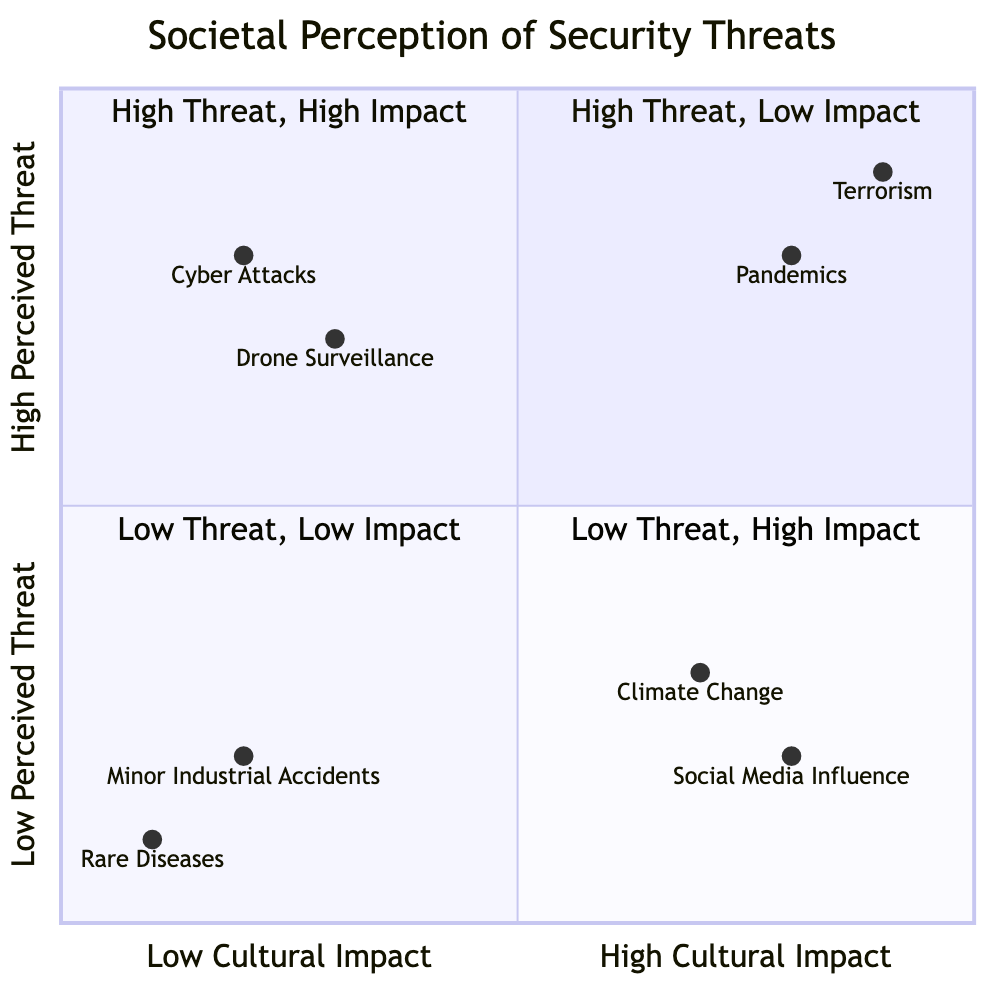What is the example for "Terrorism"? The diagram indicates that the example for "Terrorism" is "9/11 Attacks".
Answer: 9/11 Attacks How many nodes are in the "High Perceived Threat, High Cultural Impact" quadrant? The quadrant contains two nodes: "Terrorism" and "Pandemics". Thus the total count is 2.
Answer: 2 What is the perceived threat level of "Climate Change"? According to the diagram, "Climate Change" is located in the "Low Perceived Threat" category.
Answer: Low Which security threat is associated with the highest cultural impact? The diagram shows that "Terrorism" is positioned at the highest end of the cultural impact axis, indicating it has the highest cultural impact.
Answer: Terrorism Which two threats have a high perceived threat but low cultural impact? The threats "Cyber Attacks on Financial Institutions" and "Drone Surveillance" are represented in the "High Perceived Threat, Low Cultural Impact" quadrant.
Answer: Cyber Attacks on Financial Institutions and Drone Surveillance What is the cultural impact level for "Social Media Influence"? The diagram places "Social Media Influence" in the "High Cultural Impact" section, indicating its cultural impact is high.
Answer: High What threat has the least perceived threat and cultural impact? The diagram identifies "Rare Diseases" in the "Low Perceived Threat, Low Cultural Impact" quadrant, indicating it has both minimal threat levels.
Answer: Rare Diseases In which quadrant is "COVID-19 Pandemic" found? "COVID-19 Pandemic" is located in the "High Perceived Threat, High Cultural Impact" quadrant as indicated in the chart.
Answer: High Perceived Threat, High Cultural Impact What would be the cultural impact level for "Minor Industrial Accidents"? The diagram indicates that "Minor Industrial Accidents" fall in the "Low Cultural Impact" category, signifying a low cultural effect.
Answer: Low 